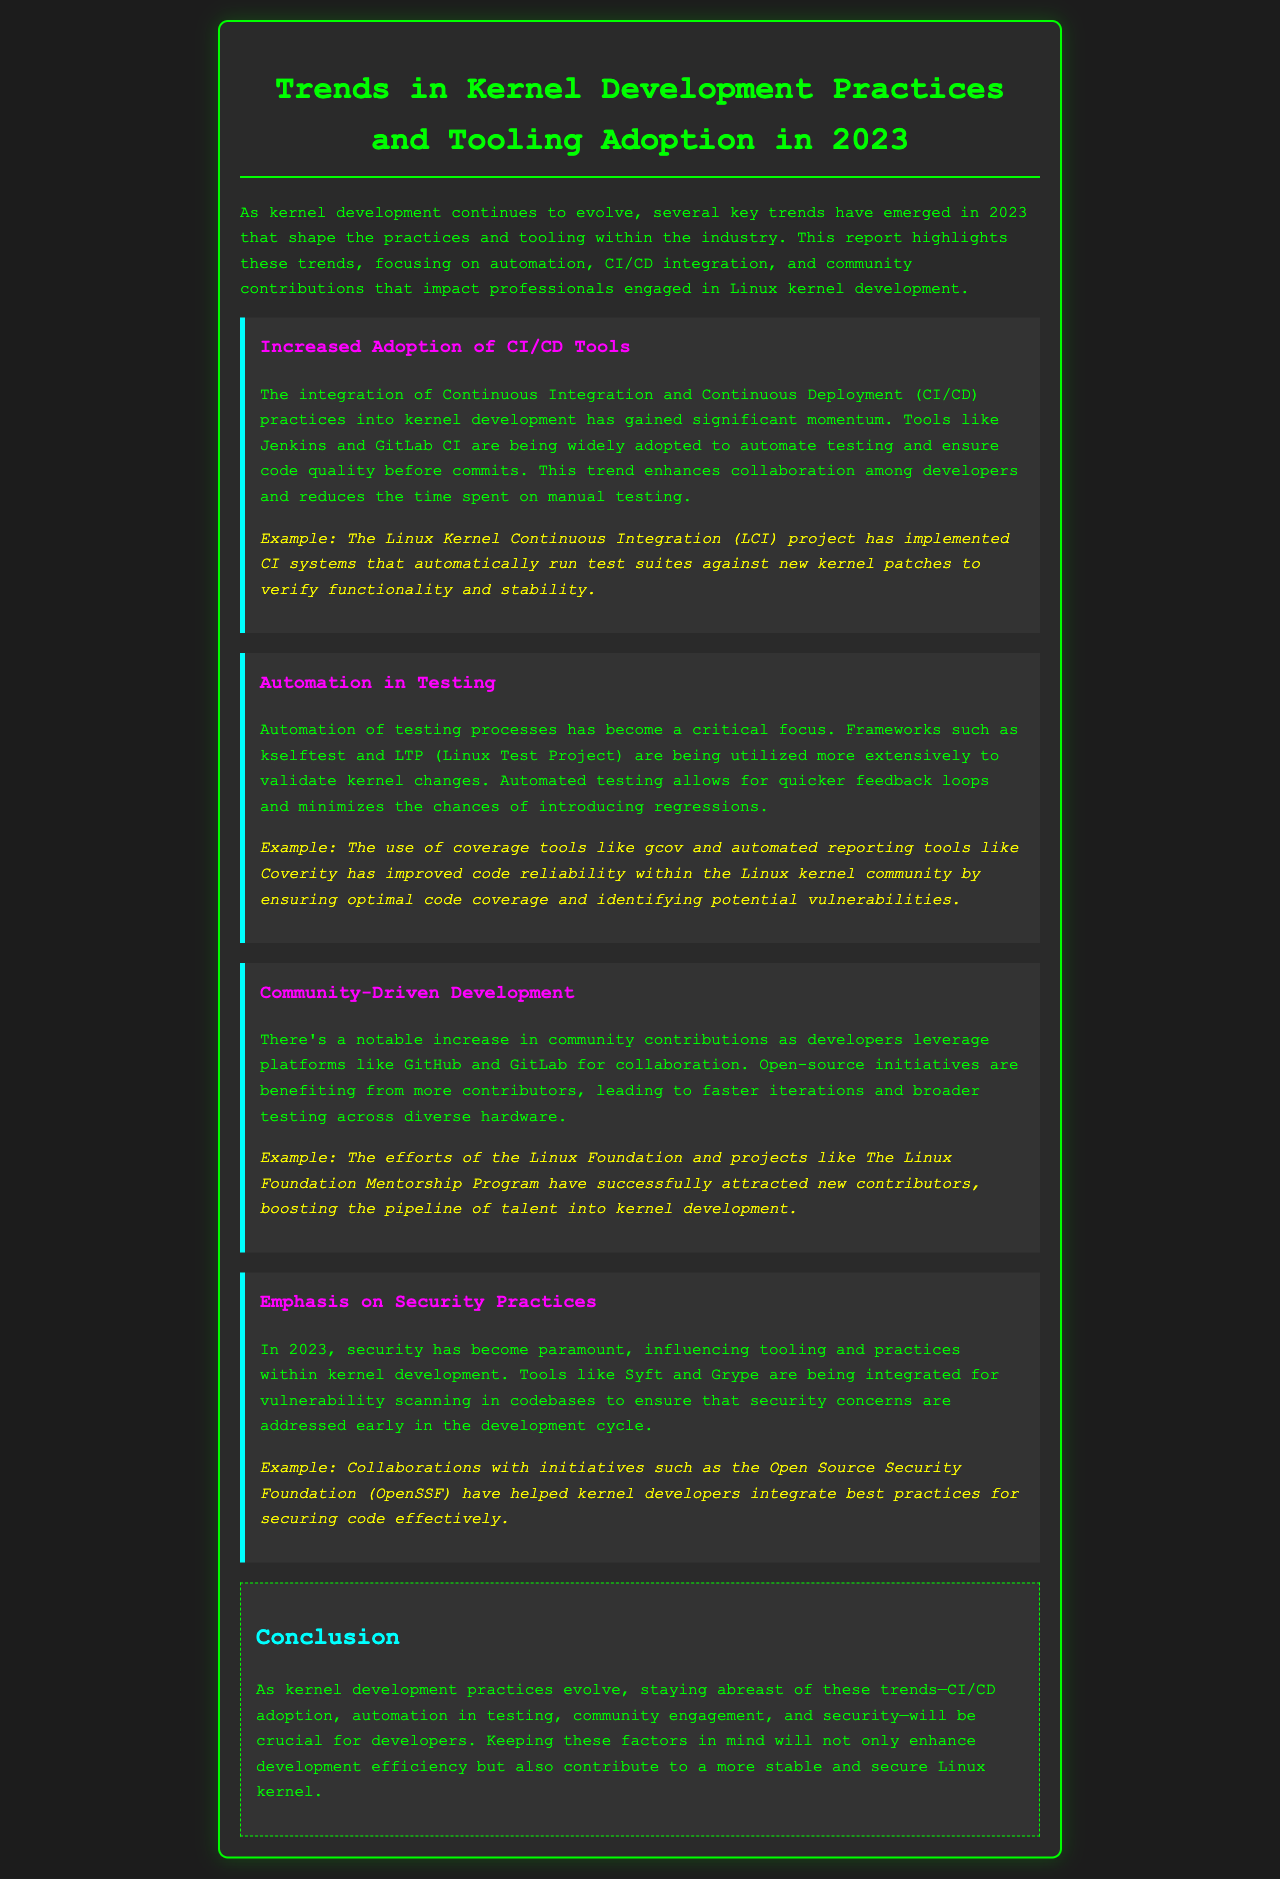What has gained momentum in kernel development? The integration of Continuous Integration and Continuous Deployment (CI/CD) practices into kernel development has gained significant momentum.
Answer: CI/CD practices Which tools are widely adopted for CI/CD in kernel development? Tools like Jenkins and GitLab CI are being widely adopted to automate testing and ensure code quality.
Answer: Jenkins and GitLab CI What project implements automated test suites for new kernel patches? The Linux Kernel Continuous Integration (LCI) project has implemented CI systems that automatically run test suites against new kernel patches.
Answer: LCI project What frameworks have become critical for testing automation? Frameworks such as kselftest and LTP (Linux Test Project) are being utilized more extensively to validate kernel changes.
Answer: kselftest and LTP What has increased in 2023 regarding community contributions? There’s a notable increase in community contributions as developers leverage platforms like GitHub and GitLab for collaboration.
Answer: Increase in community contributions Which tools are integrated for vulnerability scanning in codebases? Tools like Syft and Grype are being integrated for vulnerability scanning in codebases.
Answer: Syft and Grype What initiative has attracted new contributors to kernel development? The Linux Foundation Mentorship Program has successfully attracted new contributors.
Answer: Linux Foundation Mentorship Program What is paramount influencing tooling and practices in 2023? Security has become paramount, influencing tooling and practices within kernel development.
Answer: Security What do the trends in kernel development contribute to? Keeping these factors in mind will enhance development efficiency and contribute to a more stable and secure Linux kernel.
Answer: Development efficiency and security 